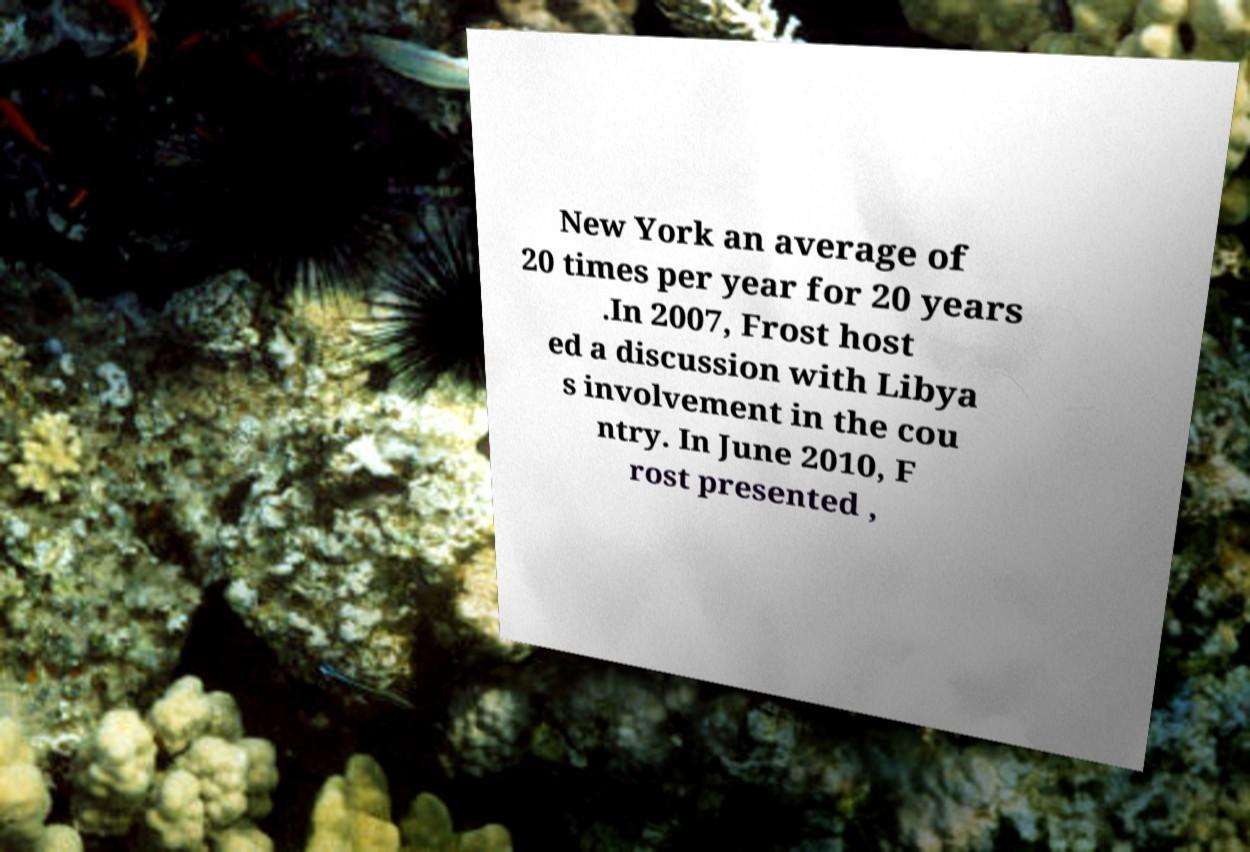Can you read and provide the text displayed in the image?This photo seems to have some interesting text. Can you extract and type it out for me? New York an average of 20 times per year for 20 years .In 2007, Frost host ed a discussion with Libya s involvement in the cou ntry. In June 2010, F rost presented , 